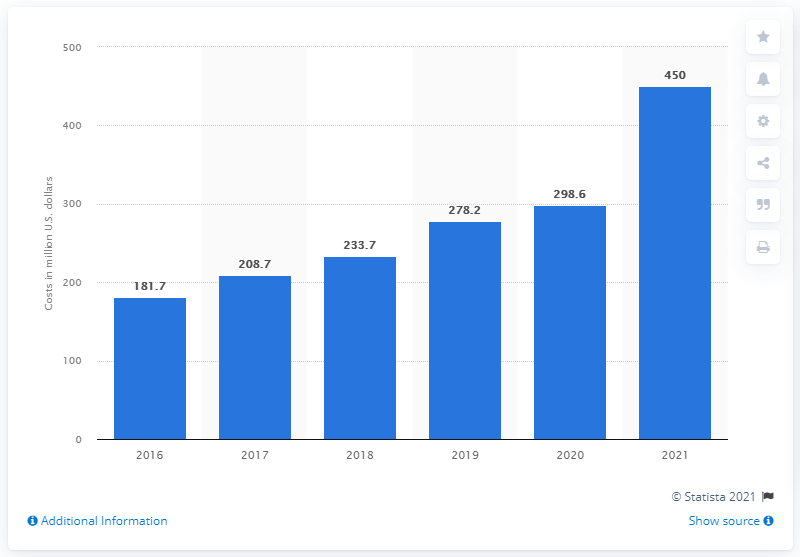Outline some significant characteristics in this image. Logitech spent $298.6 million on advertising in 2020. Logitech spent approximately 450 million dollars on advertising in 2021. In 2021, Logitech first reported advertising costs. This information was reported in 2016. 